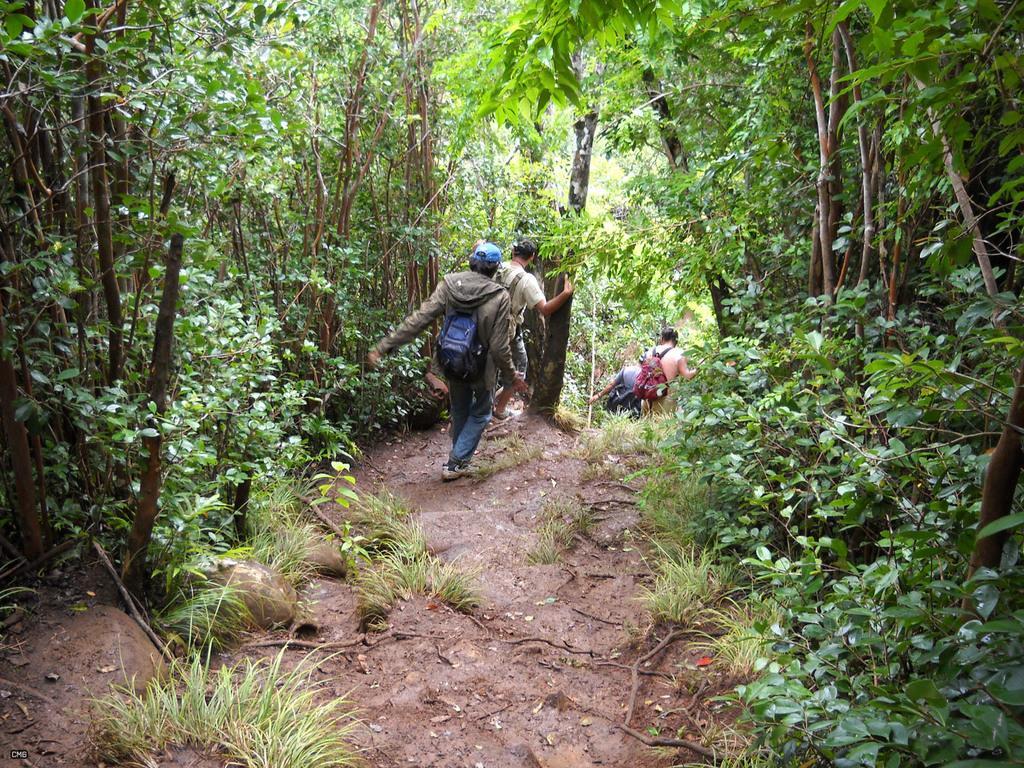Please provide a concise description of this image. In this picture we can see some people, plants on the ground and in the background we can see trees. 